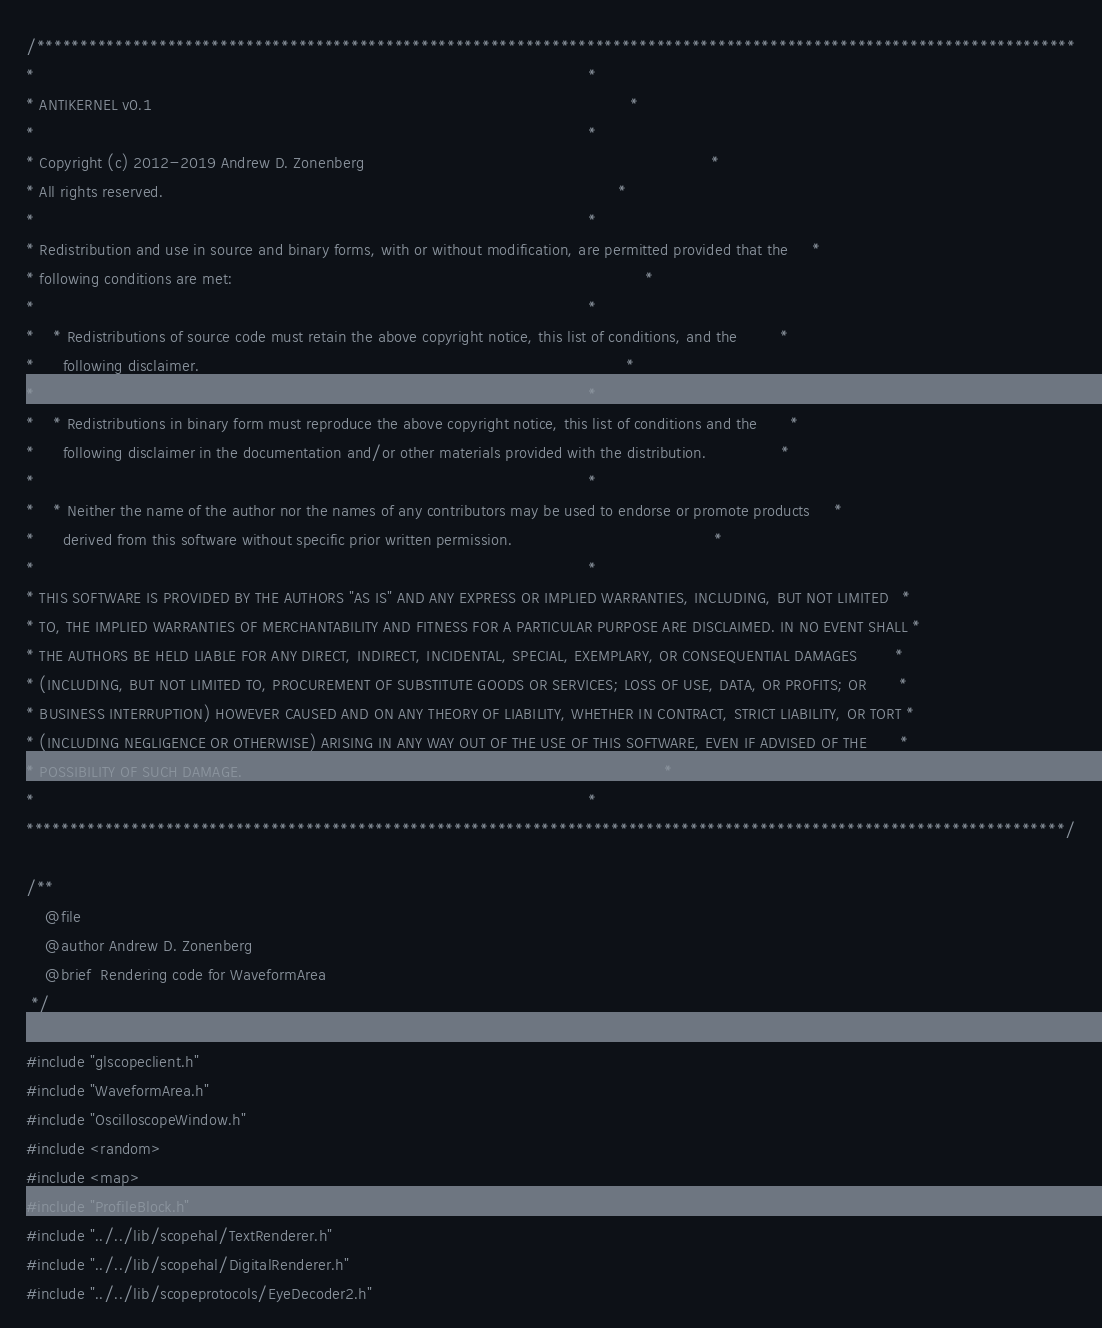Convert code to text. <code><loc_0><loc_0><loc_500><loc_500><_C++_>/***********************************************************************************************************************
*                                                                                                                      *
* ANTIKERNEL v0.1                                                                                                      *
*                                                                                                                      *
* Copyright (c) 2012-2019 Andrew D. Zonenberg                                                                          *
* All rights reserved.                                                                                                 *
*                                                                                                                      *
* Redistribution and use in source and binary forms, with or without modification, are permitted provided that the     *
* following conditions are met:                                                                                        *
*                                                                                                                      *
*    * Redistributions of source code must retain the above copyright notice, this list of conditions, and the         *
*      following disclaimer.                                                                                           *
*                                                                                                                      *
*    * Redistributions in binary form must reproduce the above copyright notice, this list of conditions and the       *
*      following disclaimer in the documentation and/or other materials provided with the distribution.                *
*                                                                                                                      *
*    * Neither the name of the author nor the names of any contributors may be used to endorse or promote products     *
*      derived from this software without specific prior written permission.                                           *
*                                                                                                                      *
* THIS SOFTWARE IS PROVIDED BY THE AUTHORS "AS IS" AND ANY EXPRESS OR IMPLIED WARRANTIES, INCLUDING, BUT NOT LIMITED   *
* TO, THE IMPLIED WARRANTIES OF MERCHANTABILITY AND FITNESS FOR A PARTICULAR PURPOSE ARE DISCLAIMED. IN NO EVENT SHALL *
* THE AUTHORS BE HELD LIABLE FOR ANY DIRECT, INDIRECT, INCIDENTAL, SPECIAL, EXEMPLARY, OR CONSEQUENTIAL DAMAGES        *
* (INCLUDING, BUT NOT LIMITED TO, PROCUREMENT OF SUBSTITUTE GOODS OR SERVICES; LOSS OF USE, DATA, OR PROFITS; OR       *
* BUSINESS INTERRUPTION) HOWEVER CAUSED AND ON ANY THEORY OF LIABILITY, WHETHER IN CONTRACT, STRICT LIABILITY, OR TORT *
* (INCLUDING NEGLIGENCE OR OTHERWISE) ARISING IN ANY WAY OUT OF THE USE OF THIS SOFTWARE, EVEN IF ADVISED OF THE       *
* POSSIBILITY OF SUCH DAMAGE.                                                                                          *
*                                                                                                                      *
***********************************************************************************************************************/

/**
	@file
	@author Andrew D. Zonenberg
	@brief  Rendering code for WaveformArea
 */

#include "glscopeclient.h"
#include "WaveformArea.h"
#include "OscilloscopeWindow.h"
#include <random>
#include <map>
#include "ProfileBlock.h"
#include "../../lib/scopehal/TextRenderer.h"
#include "../../lib/scopehal/DigitalRenderer.h"
#include "../../lib/scopeprotocols/EyeDecoder2.h"</code> 